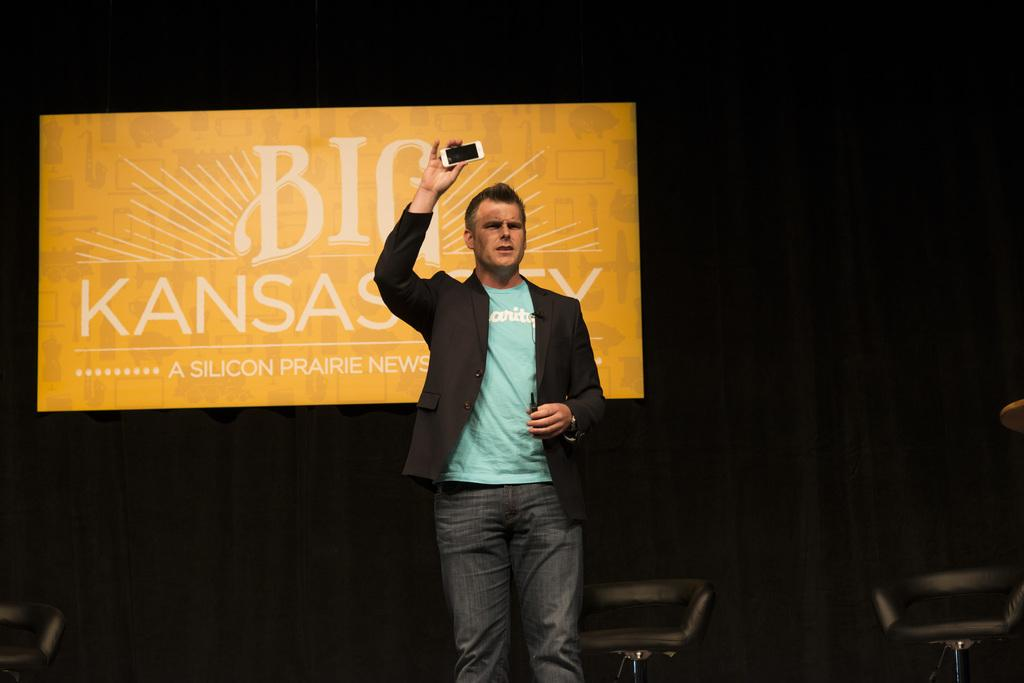Who is present in the image? There is a man in the image. What is the man doing in the image? The man is standing in the image. What object is the man holding in the image? The man is holding a phone in the image. What can be seen in the background of the image? There are chairs and a board in the background of the image. What type of houses can be seen in the background of the image? There are no houses visible in the background of the image; it only shows chairs and a board. Is there a playground in the image? There is no playground present in the image. 